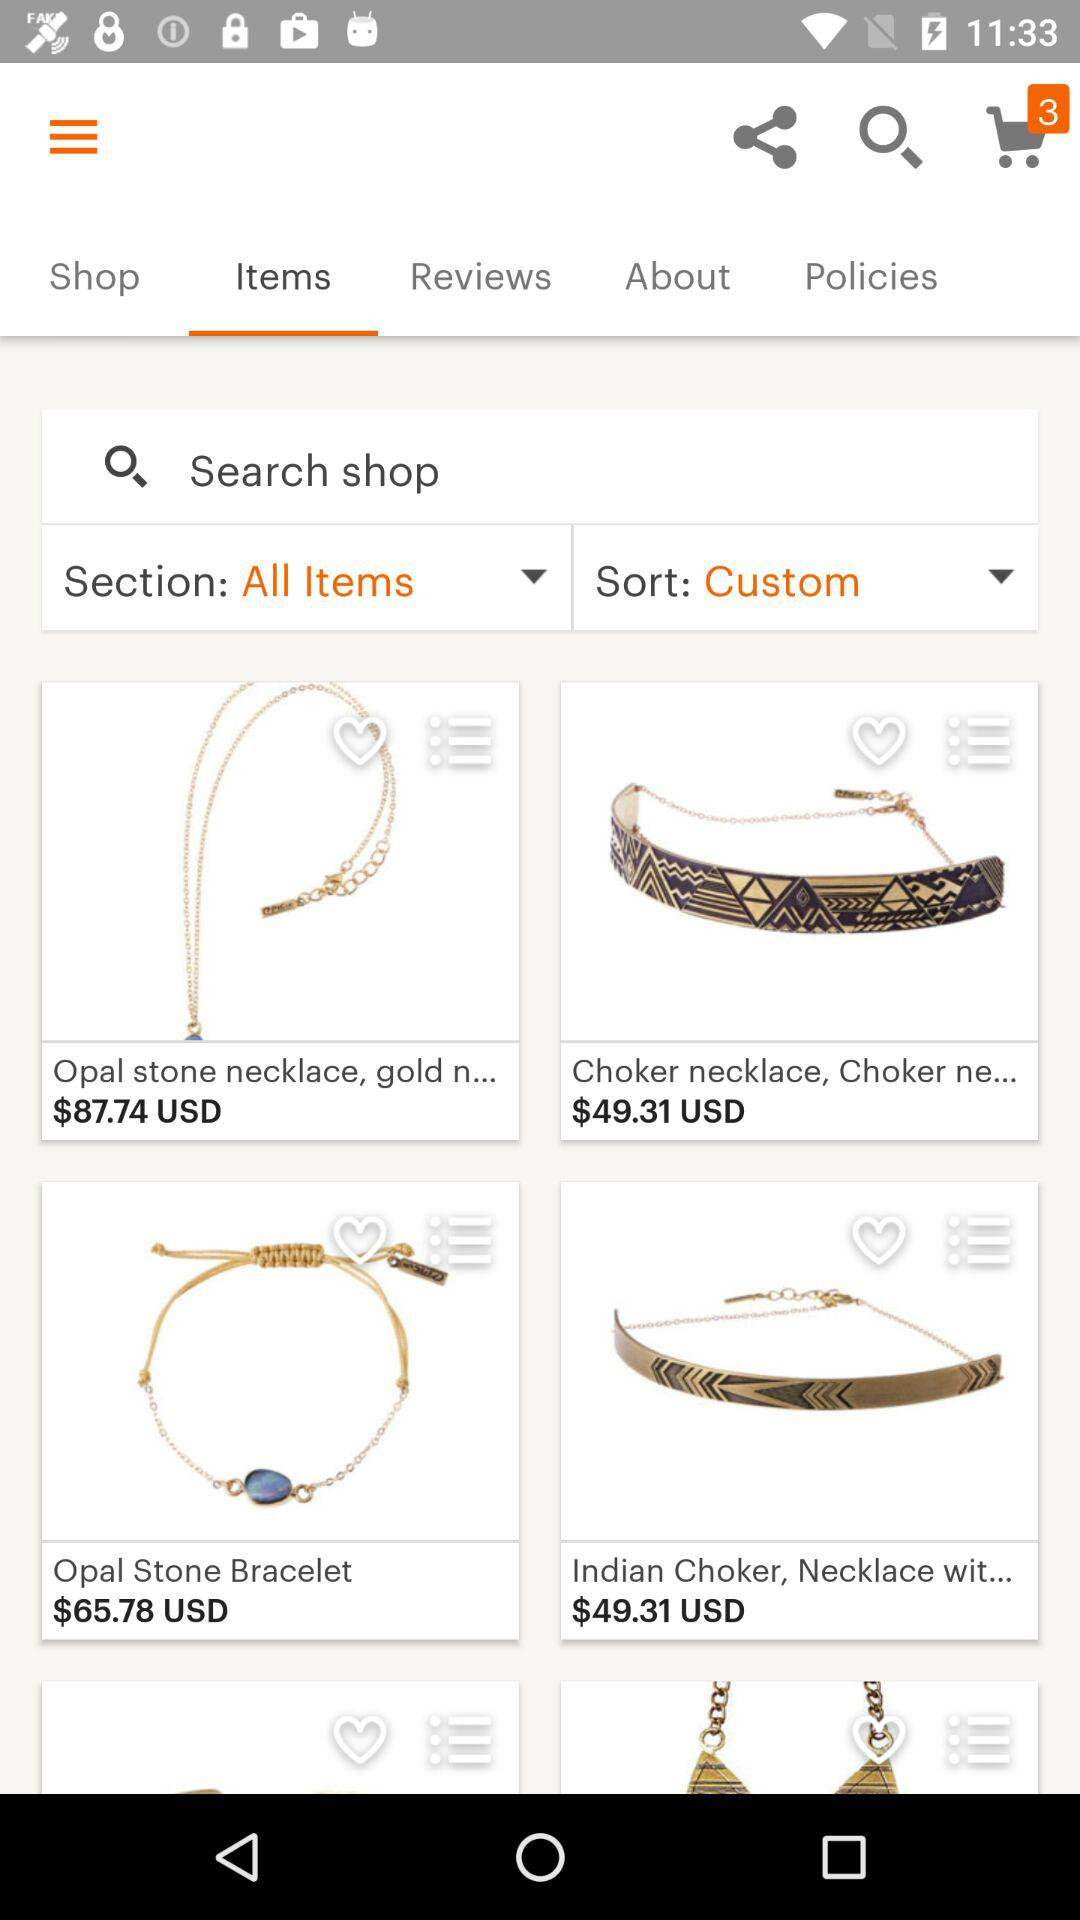How many things are added to the cart? There are 3 things added to the cart. 